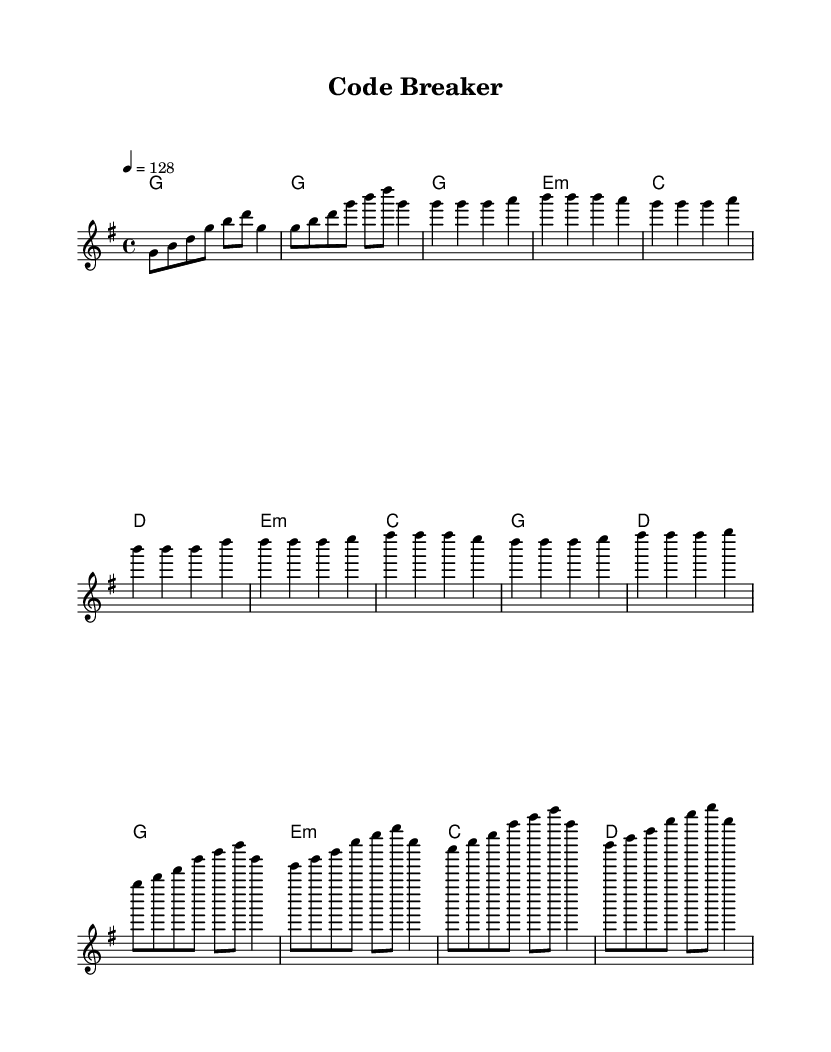What is the key signature of this music? The key signature in the sheet music is indicated by the number of sharps or flats at the beginning. Here, there are no sharps or flats, which means it is in G major.
Answer: G major What is the time signature of this piece? The time signature is located at the beginning of the score, indicating how many beats are in each measure. This piece has a time signature of 4/4, meaning there are four beats per measure.
Answer: 4/4 What is the tempo marking of this composition? The tempo is specified in beats per minute, usually found near the start of the music. This sheet music has a tempo marking of 128 beats per minute.
Answer: 128 How many measures are in the chorus? To find the number of measures, we can count the individual measures in the chorus section of the music. The chorus consists of four measures.
Answer: 4 What lyrics are associated with the pre-chorus section? The lyrics for the pre-chorus can be found directly below the music notes in the sheet. The pre-chorus lyrics are "Stack o -- ver -- flow, where do we go?"
Answer: Stack o -- ver -- flow, where do we go? What is the main theme of the song's lyrics? The lyrics discuss themes of problem-solving related to coding, particularly focusing on debugging and digital creation. This can be evidenced by phrases like "De -- bug -- ging through the night" and "We're the code break -- ers."
Answer: Problem-solving and coding Which musical element is repeated in both the verse and chorus? Examining the melodies and lyrics in both sections for similarities shows that the melody pattern structure related to problem-solving is repeated, especially in the rhythm and phrasing. The thematic content about coding challenges is also consistent throughout.
Answer: Melody and coding theme 